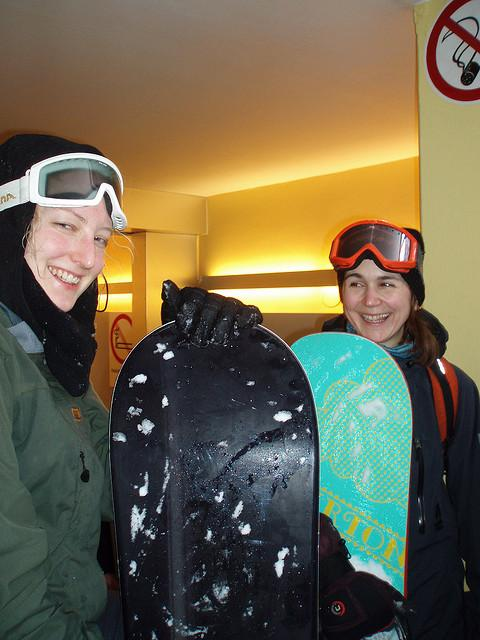What can't be done in this room? Please explain your reasoning. smoking. A sign showing a cigarette with a line through it is on the wall. 